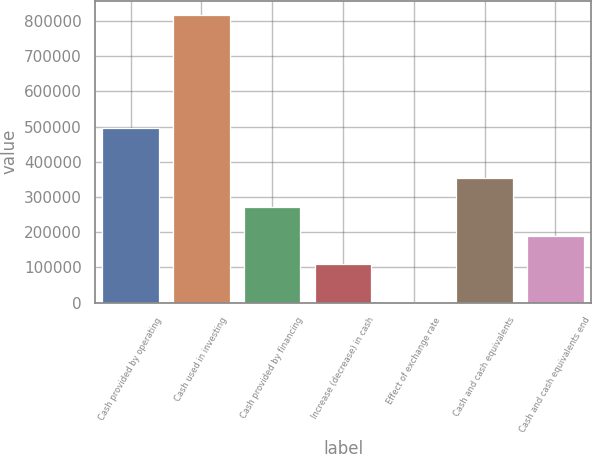Convert chart. <chart><loc_0><loc_0><loc_500><loc_500><bar_chart><fcel>Cash provided by operating<fcel>Cash used in investing<fcel>Cash provided by financing<fcel>Increase (decrease) in cash<fcel>Effect of exchange rate<fcel>Cash and cash equivalents<fcel>Cash and cash equivalents end<nl><fcel>497587<fcel>817198<fcel>271771<fcel>108774<fcel>2213<fcel>353270<fcel>190272<nl></chart> 